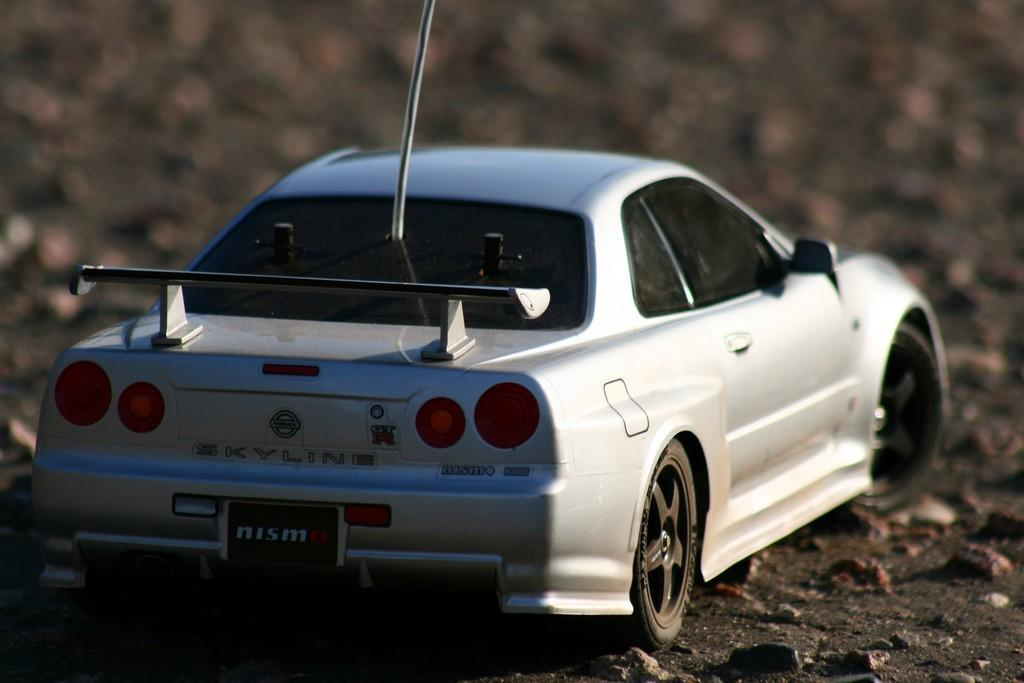What type of toy is in the image? There is a toy car in the image. What color is the toy car? The toy car is white in color. What can be seen at the bottom of the image? There are stones at the bottom of the image. What is the color of the background in the image? The background of the image is grey. How is the image blurred? The image is blurred in the background. What type of nut is being used as a punishment for the toy car in the image? There is no nut or punishment present in the image; it features a toy car and stones at the bottom. How many women are visible in the image? There are no women present in the image. 